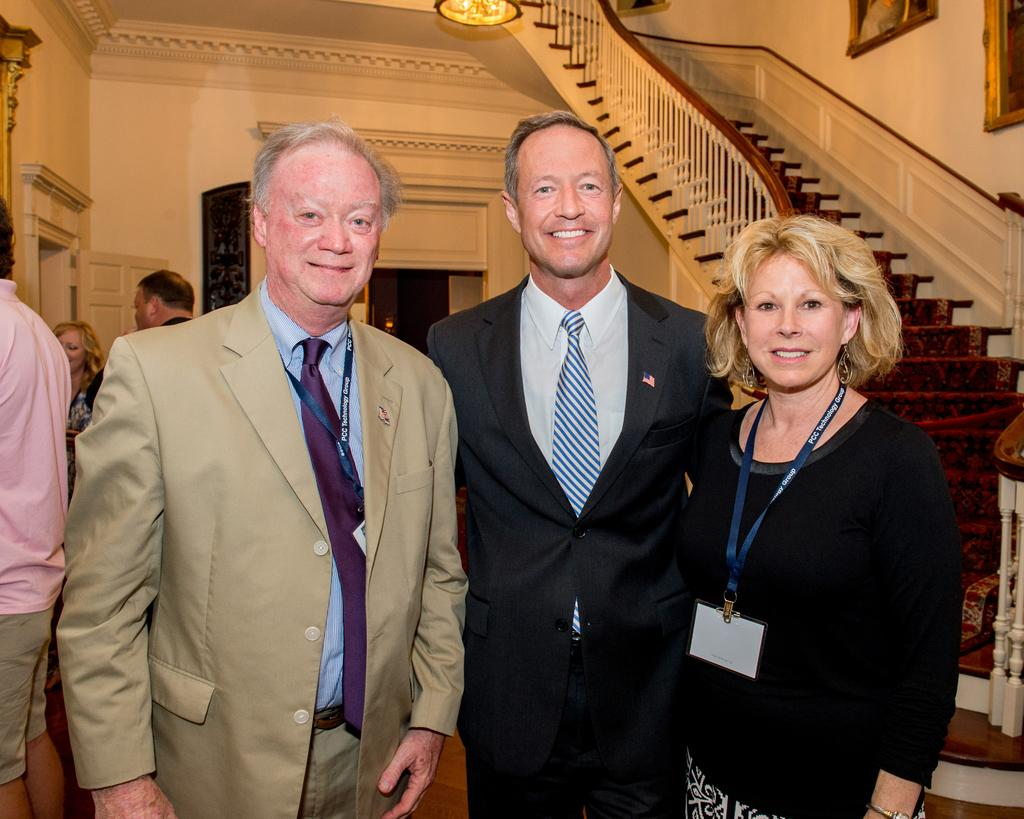What can be seen in the hall in the image? There are people in the hall in the image. What is hanging from the roof in the image? There is a light hanging from the roof in the image. What is attached to the wall in the image? There are frames attached to the wall in the image. What architectural feature is present in the image? There are stairs in the image. What is a possible entrance or exit in the image? There is a door in the image. What type of toothpaste is being advertised on the frames in the image? There is no toothpaste present in the image; the frames are attached to the wall and contain unspecified content. What is the name of the downtown area visible through the door in the image? There is no downtown area visible through the door in the image, as the door leads to an unspecified location. 